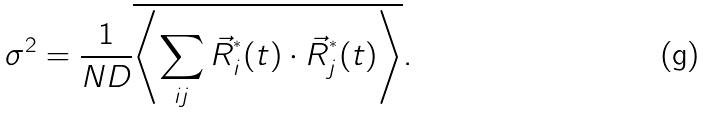<formula> <loc_0><loc_0><loc_500><loc_500>\sigma ^ { 2 } = \frac { 1 } { N D } \overline { \left \langle \sum _ { i j } \vec { R } ^ { ^ { * } } _ { i } ( t ) \cdot \vec { R } ^ { ^ { * } } _ { j } ( t ) \right \rangle } .</formula> 